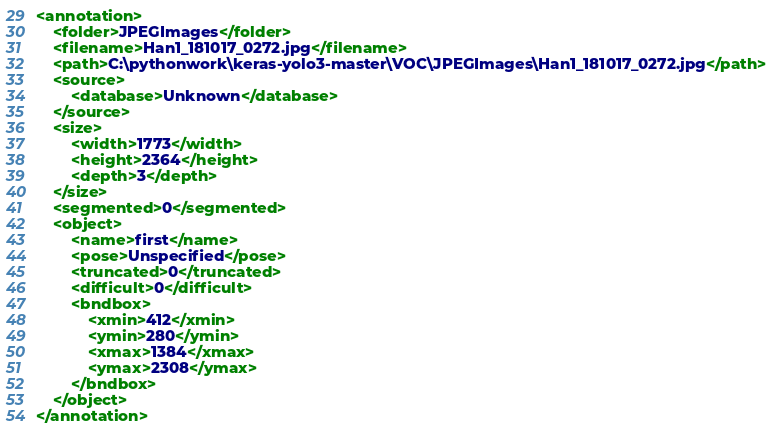Convert code to text. <code><loc_0><loc_0><loc_500><loc_500><_XML_><annotation>
	<folder>JPEGImages</folder>
	<filename>Han1_181017_0272.jpg</filename>
	<path>C:\pythonwork\keras-yolo3-master\VOC\JPEGImages\Han1_181017_0272.jpg</path>
	<source>
		<database>Unknown</database>
	</source>
	<size>
		<width>1773</width>
		<height>2364</height>
		<depth>3</depth>
	</size>
	<segmented>0</segmented>
	<object>
		<name>first</name>
		<pose>Unspecified</pose>
		<truncated>0</truncated>
		<difficult>0</difficult>
		<bndbox>
			<xmin>412</xmin>
			<ymin>280</ymin>
			<xmax>1384</xmax>
			<ymax>2308</ymax>
		</bndbox>
	</object>
</annotation>
</code> 